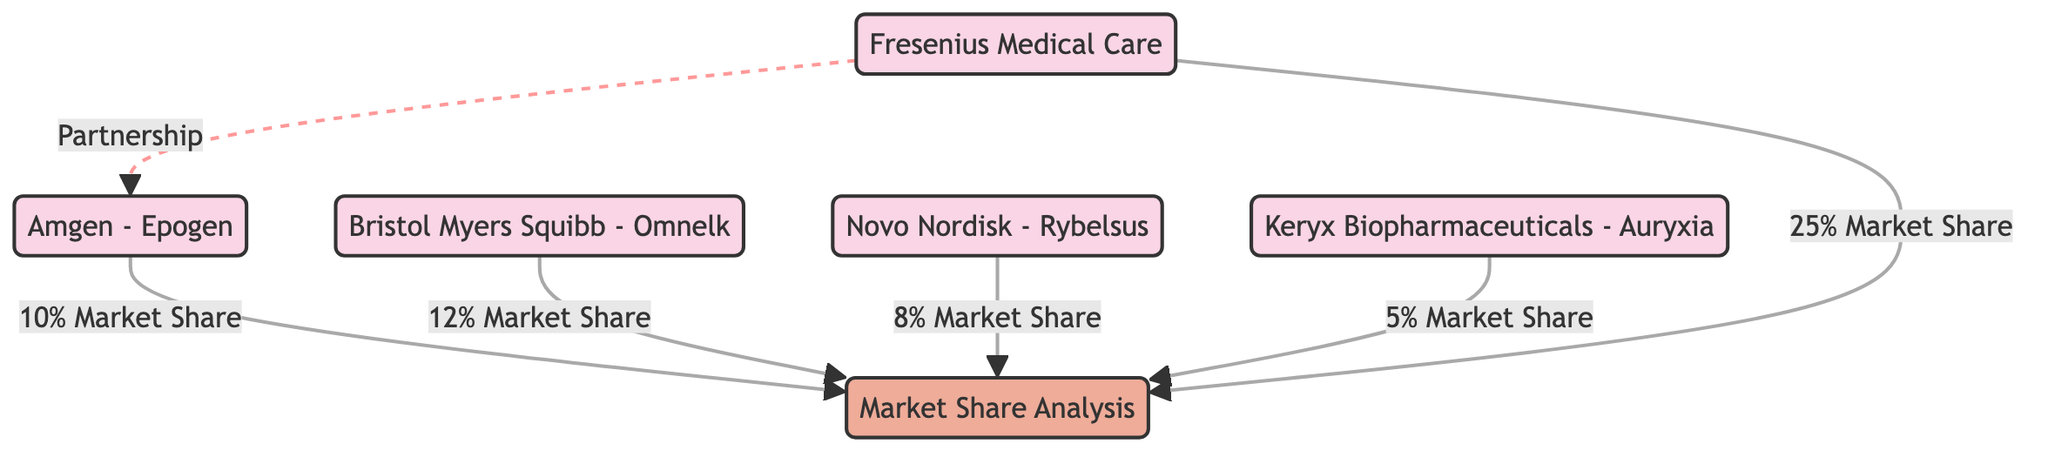What is the market share percentage of Fresenius Medical Care? The diagram shows an edge leading from the node "Fresenius Medical Care" to "Market Share Analysis" with a label indicating "25% Market Share." Therefore, the market share percentage for Fresenius Medical Care is directly visible.
Answer: 25% Market Share Which company has the lowest market share in this analysis? By examining the edges leading to "Market Share Analysis," the percentages are: 10%, 12%, 8%, 5%, and 25%. The lowest percentage is 5%, which is associated with "Keryx Biopharmaceuticals - Auryxia." Thus, the answer is derived from comparing the market shares of all listed companies.
Answer: Keryx Biopharmaceuticals - Auryxia How many total nodes are present in the diagram? The diagram lists six nodes in total: "Amgen - Epogen," "Bristol Myers Squibb - Omnelk," "Novo Nordisk - Rybelsus," "Fresenius Medical Care," "Keryx Biopharmaceuticals - Auryxia," and "Market Share Analysis." By counting these nodes, the total is found.
Answer: 6 Which product has a partnership with Amgen - Epogen? The diagram shows a dashed edge leading from "Fresenius Medical Care" to "Amgen - Epogen," which has a label stating "Partnership." Thus, the specific relationship can be directly observed.
Answer: Fresenius Medical Care What is the combined market share of Amgen - Epogen and Bristol Myers Squibb - Omnelk? From the diagram, "Amgen - Epogen" has a market share of 10% and "Bristol Myers Squibb - Omnelk" has a market share of 12%. To find the combined market share, add these two percentages together: 10% + 12% = 22%.
Answer: 22% 